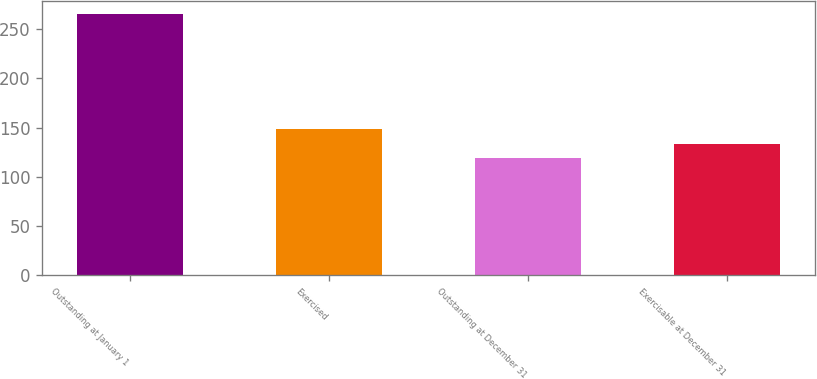Convert chart. <chart><loc_0><loc_0><loc_500><loc_500><bar_chart><fcel>Outstanding at January 1<fcel>Exercised<fcel>Outstanding at December 31<fcel>Exercisable at December 31<nl><fcel>265<fcel>148.2<fcel>119<fcel>133.6<nl></chart> 